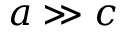Convert formula to latex. <formula><loc_0><loc_0><loc_500><loc_500>a \gg c</formula> 